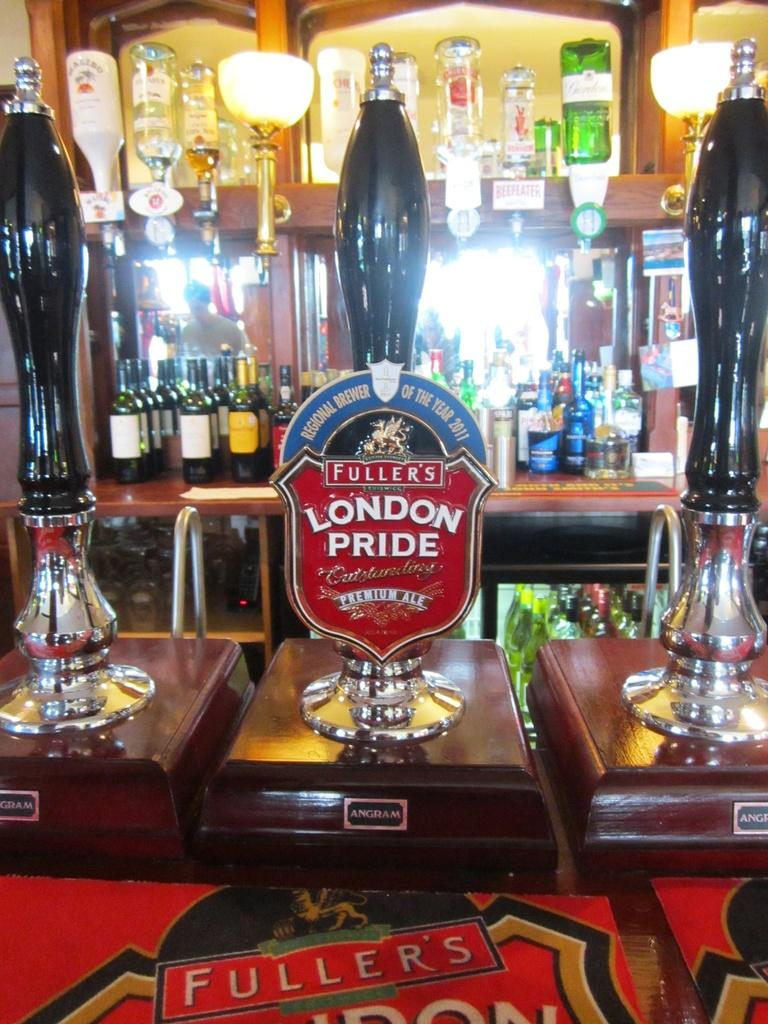<image>
Relay a brief, clear account of the picture shown. In a bar there you can get a pint of Fullers London Pride. 